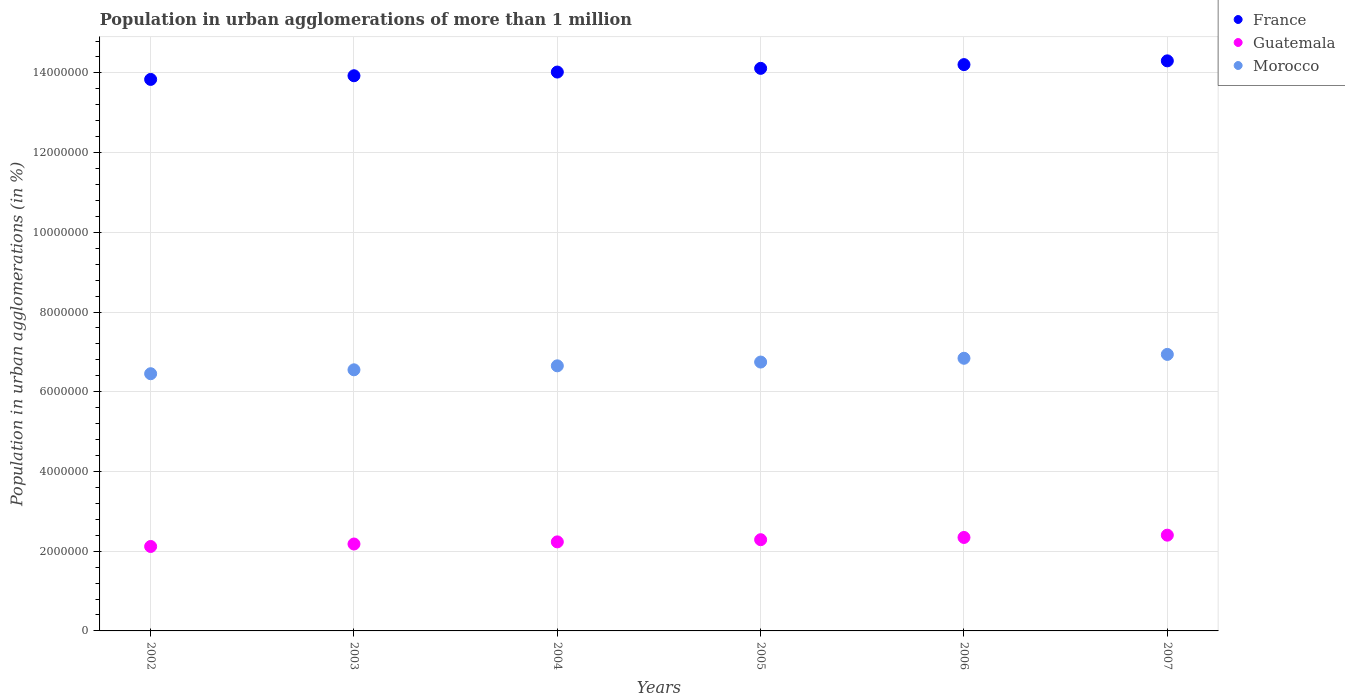How many different coloured dotlines are there?
Offer a very short reply. 3. Is the number of dotlines equal to the number of legend labels?
Provide a succinct answer. Yes. What is the population in urban agglomerations in Morocco in 2002?
Your answer should be very brief. 6.45e+06. Across all years, what is the maximum population in urban agglomerations in Morocco?
Offer a terse response. 6.94e+06. Across all years, what is the minimum population in urban agglomerations in France?
Your answer should be very brief. 1.38e+07. What is the total population in urban agglomerations in France in the graph?
Your response must be concise. 8.44e+07. What is the difference between the population in urban agglomerations in France in 2006 and that in 2007?
Give a very brief answer. -9.44e+04. What is the difference between the population in urban agglomerations in France in 2006 and the population in urban agglomerations in Guatemala in 2004?
Keep it short and to the point. 1.20e+07. What is the average population in urban agglomerations in Morocco per year?
Your response must be concise. 6.70e+06. In the year 2007, what is the difference between the population in urban agglomerations in Morocco and population in urban agglomerations in France?
Ensure brevity in your answer.  -7.36e+06. In how many years, is the population in urban agglomerations in Guatemala greater than 6000000 %?
Make the answer very short. 0. What is the ratio of the population in urban agglomerations in Guatemala in 2004 to that in 2005?
Give a very brief answer. 0.98. Is the difference between the population in urban agglomerations in Morocco in 2002 and 2007 greater than the difference between the population in urban agglomerations in France in 2002 and 2007?
Offer a terse response. No. What is the difference between the highest and the second highest population in urban agglomerations in Guatemala?
Your answer should be compact. 5.75e+04. What is the difference between the highest and the lowest population in urban agglomerations in Morocco?
Provide a short and direct response. 4.85e+05. In how many years, is the population in urban agglomerations in Morocco greater than the average population in urban agglomerations in Morocco taken over all years?
Your answer should be compact. 3. Is it the case that in every year, the sum of the population in urban agglomerations in Guatemala and population in urban agglomerations in Morocco  is greater than the population in urban agglomerations in France?
Your answer should be compact. No. Is the population in urban agglomerations in Morocco strictly greater than the population in urban agglomerations in France over the years?
Keep it short and to the point. No. How many dotlines are there?
Your answer should be very brief. 3. Does the graph contain any zero values?
Offer a very short reply. No. Does the graph contain grids?
Provide a short and direct response. Yes. How are the legend labels stacked?
Provide a succinct answer. Vertical. What is the title of the graph?
Make the answer very short. Population in urban agglomerations of more than 1 million. Does "Korea (Republic)" appear as one of the legend labels in the graph?
Keep it short and to the point. No. What is the label or title of the Y-axis?
Your response must be concise. Population in urban agglomerations (in %). What is the Population in urban agglomerations (in %) in France in 2002?
Your answer should be very brief. 1.38e+07. What is the Population in urban agglomerations (in %) of Guatemala in 2002?
Ensure brevity in your answer.  2.12e+06. What is the Population in urban agglomerations (in %) of Morocco in 2002?
Ensure brevity in your answer.  6.45e+06. What is the Population in urban agglomerations (in %) in France in 2003?
Your answer should be compact. 1.39e+07. What is the Population in urban agglomerations (in %) of Guatemala in 2003?
Your answer should be compact. 2.18e+06. What is the Population in urban agglomerations (in %) in Morocco in 2003?
Provide a succinct answer. 6.55e+06. What is the Population in urban agglomerations (in %) in France in 2004?
Provide a succinct answer. 1.40e+07. What is the Population in urban agglomerations (in %) in Guatemala in 2004?
Your answer should be compact. 2.23e+06. What is the Population in urban agglomerations (in %) in Morocco in 2004?
Your response must be concise. 6.65e+06. What is the Population in urban agglomerations (in %) of France in 2005?
Provide a succinct answer. 1.41e+07. What is the Population in urban agglomerations (in %) of Guatemala in 2005?
Ensure brevity in your answer.  2.29e+06. What is the Population in urban agglomerations (in %) in Morocco in 2005?
Make the answer very short. 6.75e+06. What is the Population in urban agglomerations (in %) of France in 2006?
Offer a very short reply. 1.42e+07. What is the Population in urban agglomerations (in %) in Guatemala in 2006?
Provide a succinct answer. 2.34e+06. What is the Population in urban agglomerations (in %) in Morocco in 2006?
Make the answer very short. 6.84e+06. What is the Population in urban agglomerations (in %) in France in 2007?
Provide a short and direct response. 1.43e+07. What is the Population in urban agglomerations (in %) of Guatemala in 2007?
Ensure brevity in your answer.  2.40e+06. What is the Population in urban agglomerations (in %) of Morocco in 2007?
Your answer should be compact. 6.94e+06. Across all years, what is the maximum Population in urban agglomerations (in %) of France?
Make the answer very short. 1.43e+07. Across all years, what is the maximum Population in urban agglomerations (in %) in Guatemala?
Your answer should be very brief. 2.40e+06. Across all years, what is the maximum Population in urban agglomerations (in %) in Morocco?
Provide a succinct answer. 6.94e+06. Across all years, what is the minimum Population in urban agglomerations (in %) in France?
Ensure brevity in your answer.  1.38e+07. Across all years, what is the minimum Population in urban agglomerations (in %) of Guatemala?
Give a very brief answer. 2.12e+06. Across all years, what is the minimum Population in urban agglomerations (in %) in Morocco?
Your response must be concise. 6.45e+06. What is the total Population in urban agglomerations (in %) of France in the graph?
Offer a very short reply. 8.44e+07. What is the total Population in urban agglomerations (in %) in Guatemala in the graph?
Offer a terse response. 1.36e+07. What is the total Population in urban agglomerations (in %) of Morocco in the graph?
Provide a short and direct response. 4.02e+07. What is the difference between the Population in urban agglomerations (in %) of France in 2002 and that in 2003?
Give a very brief answer. -9.18e+04. What is the difference between the Population in urban agglomerations (in %) of Guatemala in 2002 and that in 2003?
Offer a very short reply. -6.19e+04. What is the difference between the Population in urban agglomerations (in %) in Morocco in 2002 and that in 2003?
Your answer should be very brief. -9.82e+04. What is the difference between the Population in urban agglomerations (in %) in France in 2002 and that in 2004?
Offer a terse response. -1.84e+05. What is the difference between the Population in urban agglomerations (in %) of Guatemala in 2002 and that in 2004?
Offer a terse response. -1.15e+05. What is the difference between the Population in urban agglomerations (in %) in Morocco in 2002 and that in 2004?
Your answer should be very brief. -1.98e+05. What is the difference between the Population in urban agglomerations (in %) in France in 2002 and that in 2005?
Ensure brevity in your answer.  -2.77e+05. What is the difference between the Population in urban agglomerations (in %) in Guatemala in 2002 and that in 2005?
Ensure brevity in your answer.  -1.70e+05. What is the difference between the Population in urban agglomerations (in %) of Morocco in 2002 and that in 2005?
Your answer should be very brief. -2.93e+05. What is the difference between the Population in urban agglomerations (in %) in France in 2002 and that in 2006?
Make the answer very short. -3.71e+05. What is the difference between the Population in urban agglomerations (in %) of Guatemala in 2002 and that in 2006?
Ensure brevity in your answer.  -2.26e+05. What is the difference between the Population in urban agglomerations (in %) of Morocco in 2002 and that in 2006?
Ensure brevity in your answer.  -3.88e+05. What is the difference between the Population in urban agglomerations (in %) in France in 2002 and that in 2007?
Provide a succinct answer. -4.65e+05. What is the difference between the Population in urban agglomerations (in %) in Guatemala in 2002 and that in 2007?
Provide a short and direct response. -2.84e+05. What is the difference between the Population in urban agglomerations (in %) in Morocco in 2002 and that in 2007?
Keep it short and to the point. -4.85e+05. What is the difference between the Population in urban agglomerations (in %) in France in 2003 and that in 2004?
Provide a short and direct response. -9.26e+04. What is the difference between the Population in urban agglomerations (in %) of Guatemala in 2003 and that in 2004?
Your answer should be compact. -5.36e+04. What is the difference between the Population in urban agglomerations (in %) of Morocco in 2003 and that in 2004?
Make the answer very short. -9.99e+04. What is the difference between the Population in urban agglomerations (in %) of France in 2003 and that in 2005?
Offer a very short reply. -1.86e+05. What is the difference between the Population in urban agglomerations (in %) in Guatemala in 2003 and that in 2005?
Offer a very short reply. -1.08e+05. What is the difference between the Population in urban agglomerations (in %) in Morocco in 2003 and that in 2005?
Your answer should be compact. -1.95e+05. What is the difference between the Population in urban agglomerations (in %) of France in 2003 and that in 2006?
Provide a succinct answer. -2.79e+05. What is the difference between the Population in urban agglomerations (in %) of Guatemala in 2003 and that in 2006?
Your response must be concise. -1.64e+05. What is the difference between the Population in urban agglomerations (in %) in Morocco in 2003 and that in 2006?
Give a very brief answer. -2.90e+05. What is the difference between the Population in urban agglomerations (in %) of France in 2003 and that in 2007?
Ensure brevity in your answer.  -3.74e+05. What is the difference between the Population in urban agglomerations (in %) in Guatemala in 2003 and that in 2007?
Offer a terse response. -2.22e+05. What is the difference between the Population in urban agglomerations (in %) of Morocco in 2003 and that in 2007?
Make the answer very short. -3.87e+05. What is the difference between the Population in urban agglomerations (in %) in France in 2004 and that in 2005?
Ensure brevity in your answer.  -9.30e+04. What is the difference between the Population in urban agglomerations (in %) of Guatemala in 2004 and that in 2005?
Your answer should be compact. -5.47e+04. What is the difference between the Population in urban agglomerations (in %) of Morocco in 2004 and that in 2005?
Ensure brevity in your answer.  -9.46e+04. What is the difference between the Population in urban agglomerations (in %) in France in 2004 and that in 2006?
Your answer should be compact. -1.87e+05. What is the difference between the Population in urban agglomerations (in %) in Guatemala in 2004 and that in 2006?
Your response must be concise. -1.11e+05. What is the difference between the Population in urban agglomerations (in %) of Morocco in 2004 and that in 2006?
Provide a succinct answer. -1.90e+05. What is the difference between the Population in urban agglomerations (in %) of France in 2004 and that in 2007?
Provide a succinct answer. -2.81e+05. What is the difference between the Population in urban agglomerations (in %) in Guatemala in 2004 and that in 2007?
Offer a very short reply. -1.68e+05. What is the difference between the Population in urban agglomerations (in %) of Morocco in 2004 and that in 2007?
Provide a short and direct response. -2.87e+05. What is the difference between the Population in urban agglomerations (in %) of France in 2005 and that in 2006?
Provide a succinct answer. -9.37e+04. What is the difference between the Population in urban agglomerations (in %) in Guatemala in 2005 and that in 2006?
Your answer should be compact. -5.62e+04. What is the difference between the Population in urban agglomerations (in %) of Morocco in 2005 and that in 2006?
Offer a very short reply. -9.51e+04. What is the difference between the Population in urban agglomerations (in %) in France in 2005 and that in 2007?
Your response must be concise. -1.88e+05. What is the difference between the Population in urban agglomerations (in %) of Guatemala in 2005 and that in 2007?
Your answer should be compact. -1.14e+05. What is the difference between the Population in urban agglomerations (in %) in Morocco in 2005 and that in 2007?
Provide a succinct answer. -1.92e+05. What is the difference between the Population in urban agglomerations (in %) in France in 2006 and that in 2007?
Ensure brevity in your answer.  -9.44e+04. What is the difference between the Population in urban agglomerations (in %) in Guatemala in 2006 and that in 2007?
Make the answer very short. -5.75e+04. What is the difference between the Population in urban agglomerations (in %) of Morocco in 2006 and that in 2007?
Provide a short and direct response. -9.69e+04. What is the difference between the Population in urban agglomerations (in %) of France in 2002 and the Population in urban agglomerations (in %) of Guatemala in 2003?
Your response must be concise. 1.17e+07. What is the difference between the Population in urban agglomerations (in %) of France in 2002 and the Population in urban agglomerations (in %) of Morocco in 2003?
Make the answer very short. 7.29e+06. What is the difference between the Population in urban agglomerations (in %) in Guatemala in 2002 and the Population in urban agglomerations (in %) in Morocco in 2003?
Offer a very short reply. -4.43e+06. What is the difference between the Population in urban agglomerations (in %) in France in 2002 and the Population in urban agglomerations (in %) in Guatemala in 2004?
Your response must be concise. 1.16e+07. What is the difference between the Population in urban agglomerations (in %) of France in 2002 and the Population in urban agglomerations (in %) of Morocco in 2004?
Your answer should be very brief. 7.19e+06. What is the difference between the Population in urban agglomerations (in %) of Guatemala in 2002 and the Population in urban agglomerations (in %) of Morocco in 2004?
Offer a terse response. -4.53e+06. What is the difference between the Population in urban agglomerations (in %) in France in 2002 and the Population in urban agglomerations (in %) in Guatemala in 2005?
Ensure brevity in your answer.  1.15e+07. What is the difference between the Population in urban agglomerations (in %) of France in 2002 and the Population in urban agglomerations (in %) of Morocco in 2005?
Provide a short and direct response. 7.09e+06. What is the difference between the Population in urban agglomerations (in %) in Guatemala in 2002 and the Population in urban agglomerations (in %) in Morocco in 2005?
Provide a short and direct response. -4.63e+06. What is the difference between the Population in urban agglomerations (in %) of France in 2002 and the Population in urban agglomerations (in %) of Guatemala in 2006?
Keep it short and to the point. 1.15e+07. What is the difference between the Population in urban agglomerations (in %) in France in 2002 and the Population in urban agglomerations (in %) in Morocco in 2006?
Give a very brief answer. 7.00e+06. What is the difference between the Population in urban agglomerations (in %) of Guatemala in 2002 and the Population in urban agglomerations (in %) of Morocco in 2006?
Offer a terse response. -4.72e+06. What is the difference between the Population in urban agglomerations (in %) of France in 2002 and the Population in urban agglomerations (in %) of Guatemala in 2007?
Your response must be concise. 1.14e+07. What is the difference between the Population in urban agglomerations (in %) of France in 2002 and the Population in urban agglomerations (in %) of Morocco in 2007?
Your answer should be very brief. 6.90e+06. What is the difference between the Population in urban agglomerations (in %) of Guatemala in 2002 and the Population in urban agglomerations (in %) of Morocco in 2007?
Give a very brief answer. -4.82e+06. What is the difference between the Population in urban agglomerations (in %) in France in 2003 and the Population in urban agglomerations (in %) in Guatemala in 2004?
Your response must be concise. 1.17e+07. What is the difference between the Population in urban agglomerations (in %) in France in 2003 and the Population in urban agglomerations (in %) in Morocco in 2004?
Make the answer very short. 7.28e+06. What is the difference between the Population in urban agglomerations (in %) of Guatemala in 2003 and the Population in urban agglomerations (in %) of Morocco in 2004?
Offer a very short reply. -4.47e+06. What is the difference between the Population in urban agglomerations (in %) in France in 2003 and the Population in urban agglomerations (in %) in Guatemala in 2005?
Provide a short and direct response. 1.16e+07. What is the difference between the Population in urban agglomerations (in %) of France in 2003 and the Population in urban agglomerations (in %) of Morocco in 2005?
Keep it short and to the point. 7.18e+06. What is the difference between the Population in urban agglomerations (in %) in Guatemala in 2003 and the Population in urban agglomerations (in %) in Morocco in 2005?
Give a very brief answer. -4.57e+06. What is the difference between the Population in urban agglomerations (in %) in France in 2003 and the Population in urban agglomerations (in %) in Guatemala in 2006?
Make the answer very short. 1.16e+07. What is the difference between the Population in urban agglomerations (in %) in France in 2003 and the Population in urban agglomerations (in %) in Morocco in 2006?
Provide a succinct answer. 7.09e+06. What is the difference between the Population in urban agglomerations (in %) of Guatemala in 2003 and the Population in urban agglomerations (in %) of Morocco in 2006?
Keep it short and to the point. -4.66e+06. What is the difference between the Population in urban agglomerations (in %) of France in 2003 and the Population in urban agglomerations (in %) of Guatemala in 2007?
Offer a terse response. 1.15e+07. What is the difference between the Population in urban agglomerations (in %) in France in 2003 and the Population in urban agglomerations (in %) in Morocco in 2007?
Ensure brevity in your answer.  6.99e+06. What is the difference between the Population in urban agglomerations (in %) in Guatemala in 2003 and the Population in urban agglomerations (in %) in Morocco in 2007?
Provide a short and direct response. -4.76e+06. What is the difference between the Population in urban agglomerations (in %) of France in 2004 and the Population in urban agglomerations (in %) of Guatemala in 2005?
Provide a short and direct response. 1.17e+07. What is the difference between the Population in urban agglomerations (in %) of France in 2004 and the Population in urban agglomerations (in %) of Morocco in 2005?
Give a very brief answer. 7.28e+06. What is the difference between the Population in urban agglomerations (in %) of Guatemala in 2004 and the Population in urban agglomerations (in %) of Morocco in 2005?
Provide a short and direct response. -4.51e+06. What is the difference between the Population in urban agglomerations (in %) in France in 2004 and the Population in urban agglomerations (in %) in Guatemala in 2006?
Your response must be concise. 1.17e+07. What is the difference between the Population in urban agglomerations (in %) of France in 2004 and the Population in urban agglomerations (in %) of Morocco in 2006?
Your response must be concise. 7.18e+06. What is the difference between the Population in urban agglomerations (in %) in Guatemala in 2004 and the Population in urban agglomerations (in %) in Morocco in 2006?
Offer a very short reply. -4.61e+06. What is the difference between the Population in urban agglomerations (in %) in France in 2004 and the Population in urban agglomerations (in %) in Guatemala in 2007?
Provide a succinct answer. 1.16e+07. What is the difference between the Population in urban agglomerations (in %) in France in 2004 and the Population in urban agglomerations (in %) in Morocco in 2007?
Your response must be concise. 7.08e+06. What is the difference between the Population in urban agglomerations (in %) of Guatemala in 2004 and the Population in urban agglomerations (in %) of Morocco in 2007?
Offer a very short reply. -4.70e+06. What is the difference between the Population in urban agglomerations (in %) in France in 2005 and the Population in urban agglomerations (in %) in Guatemala in 2006?
Make the answer very short. 1.18e+07. What is the difference between the Population in urban agglomerations (in %) of France in 2005 and the Population in urban agglomerations (in %) of Morocco in 2006?
Your answer should be very brief. 7.27e+06. What is the difference between the Population in urban agglomerations (in %) in Guatemala in 2005 and the Population in urban agglomerations (in %) in Morocco in 2006?
Your answer should be very brief. -4.55e+06. What is the difference between the Population in urban agglomerations (in %) of France in 2005 and the Population in urban agglomerations (in %) of Guatemala in 2007?
Keep it short and to the point. 1.17e+07. What is the difference between the Population in urban agglomerations (in %) of France in 2005 and the Population in urban agglomerations (in %) of Morocco in 2007?
Give a very brief answer. 7.18e+06. What is the difference between the Population in urban agglomerations (in %) in Guatemala in 2005 and the Population in urban agglomerations (in %) in Morocco in 2007?
Make the answer very short. -4.65e+06. What is the difference between the Population in urban agglomerations (in %) of France in 2006 and the Population in urban agglomerations (in %) of Guatemala in 2007?
Keep it short and to the point. 1.18e+07. What is the difference between the Population in urban agglomerations (in %) of France in 2006 and the Population in urban agglomerations (in %) of Morocco in 2007?
Provide a short and direct response. 7.27e+06. What is the difference between the Population in urban agglomerations (in %) of Guatemala in 2006 and the Population in urban agglomerations (in %) of Morocco in 2007?
Make the answer very short. -4.59e+06. What is the average Population in urban agglomerations (in %) in France per year?
Provide a short and direct response. 1.41e+07. What is the average Population in urban agglomerations (in %) in Guatemala per year?
Your answer should be compact. 2.26e+06. What is the average Population in urban agglomerations (in %) of Morocco per year?
Ensure brevity in your answer.  6.70e+06. In the year 2002, what is the difference between the Population in urban agglomerations (in %) of France and Population in urban agglomerations (in %) of Guatemala?
Give a very brief answer. 1.17e+07. In the year 2002, what is the difference between the Population in urban agglomerations (in %) in France and Population in urban agglomerations (in %) in Morocco?
Keep it short and to the point. 7.38e+06. In the year 2002, what is the difference between the Population in urban agglomerations (in %) of Guatemala and Population in urban agglomerations (in %) of Morocco?
Your answer should be very brief. -4.33e+06. In the year 2003, what is the difference between the Population in urban agglomerations (in %) in France and Population in urban agglomerations (in %) in Guatemala?
Make the answer very short. 1.17e+07. In the year 2003, what is the difference between the Population in urban agglomerations (in %) in France and Population in urban agglomerations (in %) in Morocco?
Ensure brevity in your answer.  7.38e+06. In the year 2003, what is the difference between the Population in urban agglomerations (in %) in Guatemala and Population in urban agglomerations (in %) in Morocco?
Give a very brief answer. -4.37e+06. In the year 2004, what is the difference between the Population in urban agglomerations (in %) in France and Population in urban agglomerations (in %) in Guatemala?
Offer a terse response. 1.18e+07. In the year 2004, what is the difference between the Population in urban agglomerations (in %) in France and Population in urban agglomerations (in %) in Morocco?
Offer a terse response. 7.37e+06. In the year 2004, what is the difference between the Population in urban agglomerations (in %) in Guatemala and Population in urban agglomerations (in %) in Morocco?
Offer a terse response. -4.42e+06. In the year 2005, what is the difference between the Population in urban agglomerations (in %) in France and Population in urban agglomerations (in %) in Guatemala?
Give a very brief answer. 1.18e+07. In the year 2005, what is the difference between the Population in urban agglomerations (in %) in France and Population in urban agglomerations (in %) in Morocco?
Your response must be concise. 7.37e+06. In the year 2005, what is the difference between the Population in urban agglomerations (in %) of Guatemala and Population in urban agglomerations (in %) of Morocco?
Give a very brief answer. -4.46e+06. In the year 2006, what is the difference between the Population in urban agglomerations (in %) in France and Population in urban agglomerations (in %) in Guatemala?
Your answer should be compact. 1.19e+07. In the year 2006, what is the difference between the Population in urban agglomerations (in %) of France and Population in urban agglomerations (in %) of Morocco?
Provide a short and direct response. 7.37e+06. In the year 2006, what is the difference between the Population in urban agglomerations (in %) in Guatemala and Population in urban agglomerations (in %) in Morocco?
Your answer should be compact. -4.50e+06. In the year 2007, what is the difference between the Population in urban agglomerations (in %) of France and Population in urban agglomerations (in %) of Guatemala?
Your answer should be compact. 1.19e+07. In the year 2007, what is the difference between the Population in urban agglomerations (in %) of France and Population in urban agglomerations (in %) of Morocco?
Provide a short and direct response. 7.36e+06. In the year 2007, what is the difference between the Population in urban agglomerations (in %) in Guatemala and Population in urban agglomerations (in %) in Morocco?
Provide a short and direct response. -4.54e+06. What is the ratio of the Population in urban agglomerations (in %) of France in 2002 to that in 2003?
Offer a very short reply. 0.99. What is the ratio of the Population in urban agglomerations (in %) in Guatemala in 2002 to that in 2003?
Your response must be concise. 0.97. What is the ratio of the Population in urban agglomerations (in %) in France in 2002 to that in 2004?
Offer a terse response. 0.99. What is the ratio of the Population in urban agglomerations (in %) of Guatemala in 2002 to that in 2004?
Provide a short and direct response. 0.95. What is the ratio of the Population in urban agglomerations (in %) of Morocco in 2002 to that in 2004?
Your answer should be very brief. 0.97. What is the ratio of the Population in urban agglomerations (in %) in France in 2002 to that in 2005?
Keep it short and to the point. 0.98. What is the ratio of the Population in urban agglomerations (in %) in Guatemala in 2002 to that in 2005?
Provide a short and direct response. 0.93. What is the ratio of the Population in urban agglomerations (in %) of Morocco in 2002 to that in 2005?
Offer a terse response. 0.96. What is the ratio of the Population in urban agglomerations (in %) in France in 2002 to that in 2006?
Make the answer very short. 0.97. What is the ratio of the Population in urban agglomerations (in %) in Guatemala in 2002 to that in 2006?
Your response must be concise. 0.9. What is the ratio of the Population in urban agglomerations (in %) in Morocco in 2002 to that in 2006?
Provide a short and direct response. 0.94. What is the ratio of the Population in urban agglomerations (in %) of France in 2002 to that in 2007?
Offer a terse response. 0.97. What is the ratio of the Population in urban agglomerations (in %) in Guatemala in 2002 to that in 2007?
Your answer should be compact. 0.88. What is the ratio of the Population in urban agglomerations (in %) of Morocco in 2002 to that in 2007?
Make the answer very short. 0.93. What is the ratio of the Population in urban agglomerations (in %) in Morocco in 2003 to that in 2004?
Make the answer very short. 0.98. What is the ratio of the Population in urban agglomerations (in %) of France in 2003 to that in 2005?
Give a very brief answer. 0.99. What is the ratio of the Population in urban agglomerations (in %) in Guatemala in 2003 to that in 2005?
Provide a short and direct response. 0.95. What is the ratio of the Population in urban agglomerations (in %) in Morocco in 2003 to that in 2005?
Provide a succinct answer. 0.97. What is the ratio of the Population in urban agglomerations (in %) of France in 2003 to that in 2006?
Make the answer very short. 0.98. What is the ratio of the Population in urban agglomerations (in %) in Guatemala in 2003 to that in 2006?
Offer a terse response. 0.93. What is the ratio of the Population in urban agglomerations (in %) in Morocco in 2003 to that in 2006?
Offer a terse response. 0.96. What is the ratio of the Population in urban agglomerations (in %) of France in 2003 to that in 2007?
Provide a succinct answer. 0.97. What is the ratio of the Population in urban agglomerations (in %) in Guatemala in 2003 to that in 2007?
Keep it short and to the point. 0.91. What is the ratio of the Population in urban agglomerations (in %) in Morocco in 2003 to that in 2007?
Provide a succinct answer. 0.94. What is the ratio of the Population in urban agglomerations (in %) of France in 2004 to that in 2005?
Your response must be concise. 0.99. What is the ratio of the Population in urban agglomerations (in %) in Guatemala in 2004 to that in 2005?
Your response must be concise. 0.98. What is the ratio of the Population in urban agglomerations (in %) of France in 2004 to that in 2006?
Offer a terse response. 0.99. What is the ratio of the Population in urban agglomerations (in %) in Guatemala in 2004 to that in 2006?
Keep it short and to the point. 0.95. What is the ratio of the Population in urban agglomerations (in %) of Morocco in 2004 to that in 2006?
Offer a very short reply. 0.97. What is the ratio of the Population in urban agglomerations (in %) in France in 2004 to that in 2007?
Your response must be concise. 0.98. What is the ratio of the Population in urban agglomerations (in %) in Guatemala in 2004 to that in 2007?
Your answer should be very brief. 0.93. What is the ratio of the Population in urban agglomerations (in %) in Morocco in 2004 to that in 2007?
Give a very brief answer. 0.96. What is the ratio of the Population in urban agglomerations (in %) of France in 2005 to that in 2006?
Your answer should be compact. 0.99. What is the ratio of the Population in urban agglomerations (in %) in Guatemala in 2005 to that in 2006?
Give a very brief answer. 0.98. What is the ratio of the Population in urban agglomerations (in %) in Morocco in 2005 to that in 2006?
Make the answer very short. 0.99. What is the ratio of the Population in urban agglomerations (in %) of Guatemala in 2005 to that in 2007?
Provide a short and direct response. 0.95. What is the ratio of the Population in urban agglomerations (in %) in Morocco in 2005 to that in 2007?
Offer a terse response. 0.97. What is the ratio of the Population in urban agglomerations (in %) of France in 2006 to that in 2007?
Offer a very short reply. 0.99. What is the ratio of the Population in urban agglomerations (in %) in Guatemala in 2006 to that in 2007?
Offer a very short reply. 0.98. What is the ratio of the Population in urban agglomerations (in %) of Morocco in 2006 to that in 2007?
Provide a succinct answer. 0.99. What is the difference between the highest and the second highest Population in urban agglomerations (in %) of France?
Provide a short and direct response. 9.44e+04. What is the difference between the highest and the second highest Population in urban agglomerations (in %) in Guatemala?
Give a very brief answer. 5.75e+04. What is the difference between the highest and the second highest Population in urban agglomerations (in %) in Morocco?
Ensure brevity in your answer.  9.69e+04. What is the difference between the highest and the lowest Population in urban agglomerations (in %) in France?
Give a very brief answer. 4.65e+05. What is the difference between the highest and the lowest Population in urban agglomerations (in %) of Guatemala?
Ensure brevity in your answer.  2.84e+05. What is the difference between the highest and the lowest Population in urban agglomerations (in %) of Morocco?
Give a very brief answer. 4.85e+05. 